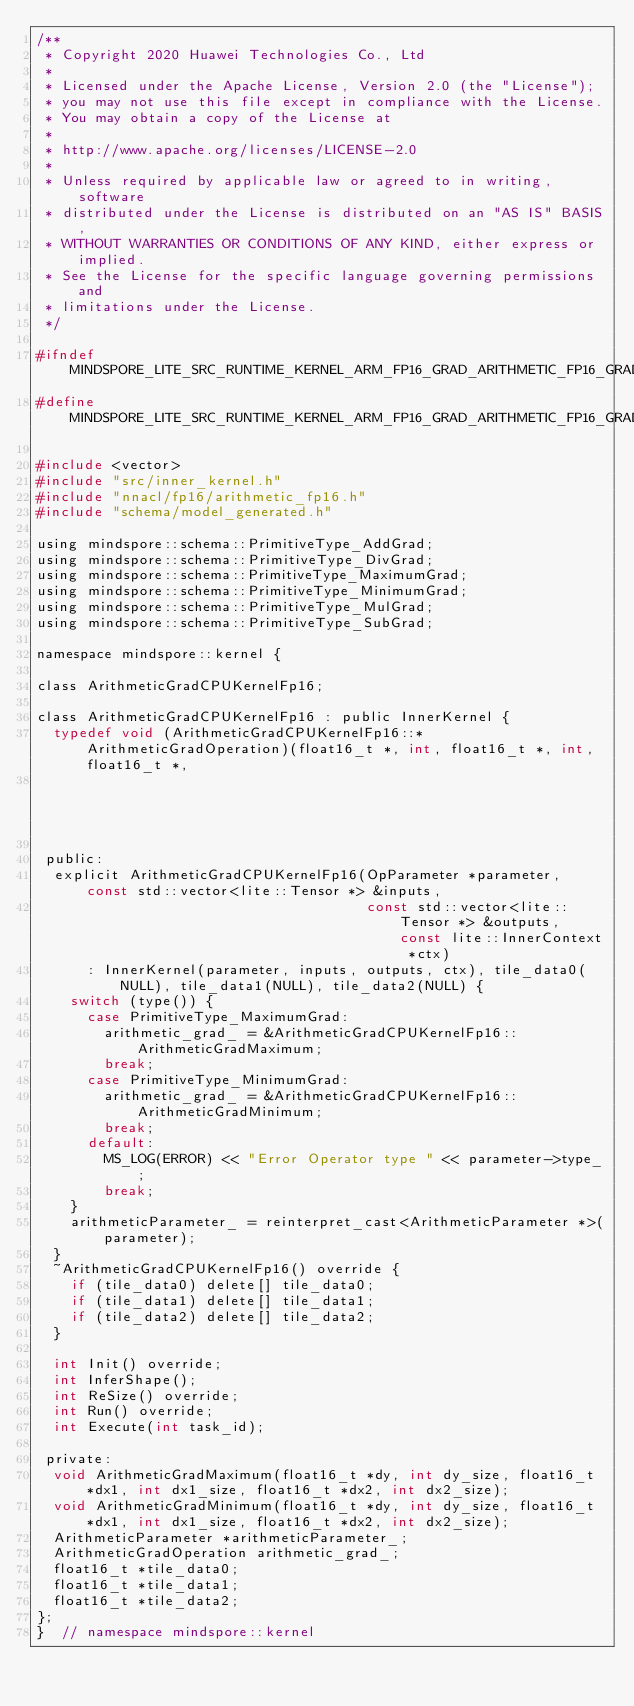<code> <loc_0><loc_0><loc_500><loc_500><_C_>/**
 * Copyright 2020 Huawei Technologies Co., Ltd
 *
 * Licensed under the Apache License, Version 2.0 (the "License");
 * you may not use this file except in compliance with the License.
 * You may obtain a copy of the License at
 *
 * http://www.apache.org/licenses/LICENSE-2.0
 *
 * Unless required by applicable law or agreed to in writing, software
 * distributed under the License is distributed on an "AS IS" BASIS,
 * WITHOUT WARRANTIES OR CONDITIONS OF ANY KIND, either express or implied.
 * See the License for the specific language governing permissions and
 * limitations under the License.
 */

#ifndef MINDSPORE_LITE_SRC_RUNTIME_KERNEL_ARM_FP16_GRAD_ARITHMETIC_FP16_GRAD_H_
#define MINDSPORE_LITE_SRC_RUNTIME_KERNEL_ARM_FP16_GRAD_ARITHMETIC_FP16_GRAD_H_

#include <vector>
#include "src/inner_kernel.h"
#include "nnacl/fp16/arithmetic_fp16.h"
#include "schema/model_generated.h"

using mindspore::schema::PrimitiveType_AddGrad;
using mindspore::schema::PrimitiveType_DivGrad;
using mindspore::schema::PrimitiveType_MaximumGrad;
using mindspore::schema::PrimitiveType_MinimumGrad;
using mindspore::schema::PrimitiveType_MulGrad;
using mindspore::schema::PrimitiveType_SubGrad;

namespace mindspore::kernel {

class ArithmeticGradCPUKernelFp16;

class ArithmeticGradCPUKernelFp16 : public InnerKernel {
  typedef void (ArithmeticGradCPUKernelFp16::*ArithmeticGradOperation)(float16_t *, int, float16_t *, int, float16_t *,
                                                                       int);

 public:
  explicit ArithmeticGradCPUKernelFp16(OpParameter *parameter, const std::vector<lite::Tensor *> &inputs,
                                       const std::vector<lite::Tensor *> &outputs, const lite::InnerContext *ctx)
      : InnerKernel(parameter, inputs, outputs, ctx), tile_data0(NULL), tile_data1(NULL), tile_data2(NULL) {
    switch (type()) {
      case PrimitiveType_MaximumGrad:
        arithmetic_grad_ = &ArithmeticGradCPUKernelFp16::ArithmeticGradMaximum;
        break;
      case PrimitiveType_MinimumGrad:
        arithmetic_grad_ = &ArithmeticGradCPUKernelFp16::ArithmeticGradMinimum;
        break;
      default:
        MS_LOG(ERROR) << "Error Operator type " << parameter->type_;
        break;
    }
    arithmeticParameter_ = reinterpret_cast<ArithmeticParameter *>(parameter);
  }
  ~ArithmeticGradCPUKernelFp16() override {
    if (tile_data0) delete[] tile_data0;
    if (tile_data1) delete[] tile_data1;
    if (tile_data2) delete[] tile_data2;
  }

  int Init() override;
  int InferShape();
  int ReSize() override;
  int Run() override;
  int Execute(int task_id);

 private:
  void ArithmeticGradMaximum(float16_t *dy, int dy_size, float16_t *dx1, int dx1_size, float16_t *dx2, int dx2_size);
  void ArithmeticGradMinimum(float16_t *dy, int dy_size, float16_t *dx1, int dx1_size, float16_t *dx2, int dx2_size);
  ArithmeticParameter *arithmeticParameter_;
  ArithmeticGradOperation arithmetic_grad_;
  float16_t *tile_data0;
  float16_t *tile_data1;
  float16_t *tile_data2;
};
}  // namespace mindspore::kernel
</code> 